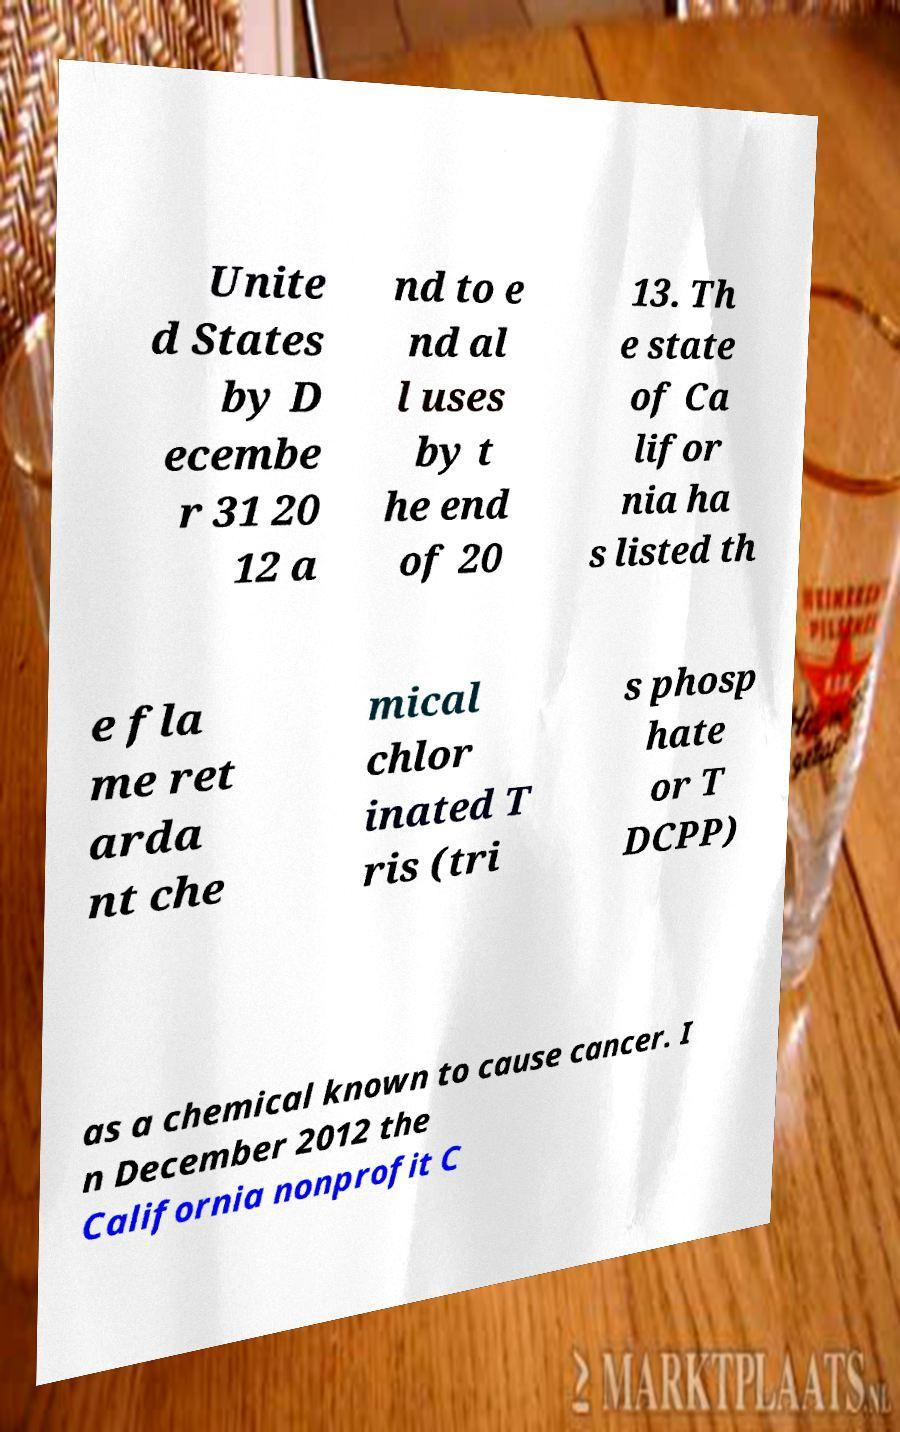Could you extract and type out the text from this image? Unite d States by D ecembe r 31 20 12 a nd to e nd al l uses by t he end of 20 13. Th e state of Ca lifor nia ha s listed th e fla me ret arda nt che mical chlor inated T ris (tri s phosp hate or T DCPP) as a chemical known to cause cancer. I n December 2012 the California nonprofit C 